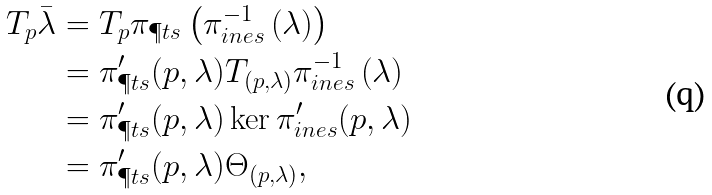Convert formula to latex. <formula><loc_0><loc_0><loc_500><loc_500>T _ { p } \bar { \lambda } & = T _ { p } \pi _ { \P t s } \left ( \pi ^ { - 1 } _ { \L i n e s } \left ( \lambda \right ) \right ) \\ & = \pi _ { \P t s } ^ { \prime } ( p , \lambda ) T _ { ( p , \lambda ) } \pi ^ { - 1 } _ { \L i n e s } \left ( \lambda \right ) \\ & = \pi _ { \P t s } ^ { \prime } ( p , \lambda ) \ker \pi ^ { \prime } _ { \L i n e s } ( p , \lambda ) \\ & = \pi _ { \P t s } ^ { \prime } ( p , \lambda ) \Theta _ { ( p , \lambda ) } ,</formula> 